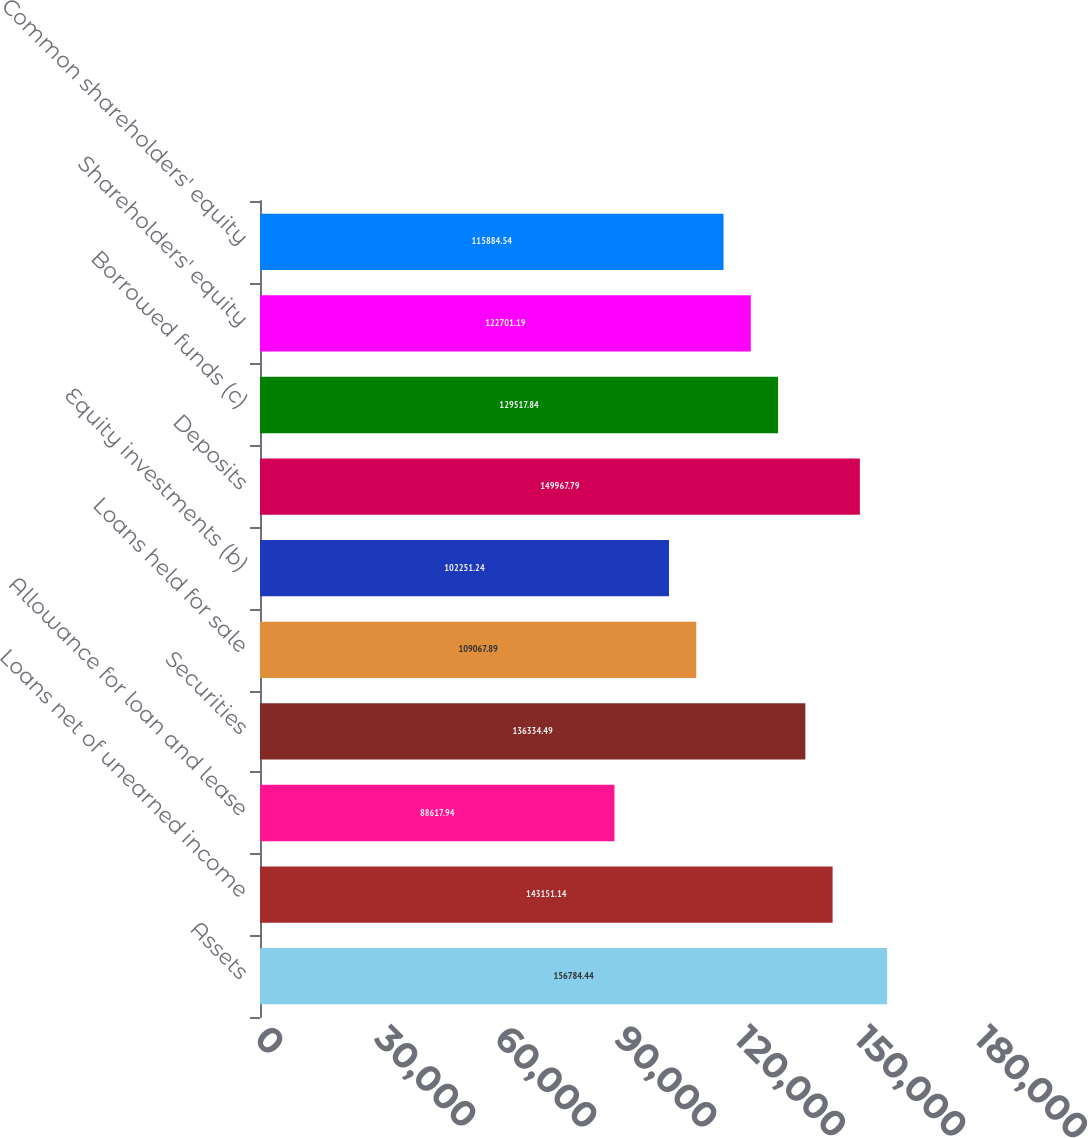<chart> <loc_0><loc_0><loc_500><loc_500><bar_chart><fcel>Assets<fcel>Loans net of unearned income<fcel>Allowance for loan and lease<fcel>Securities<fcel>Loans held for sale<fcel>Equity investments (b)<fcel>Deposits<fcel>Borrowed funds (c)<fcel>Shareholders' equity<fcel>Common shareholders' equity<nl><fcel>156784<fcel>143151<fcel>88617.9<fcel>136334<fcel>109068<fcel>102251<fcel>149968<fcel>129518<fcel>122701<fcel>115885<nl></chart> 